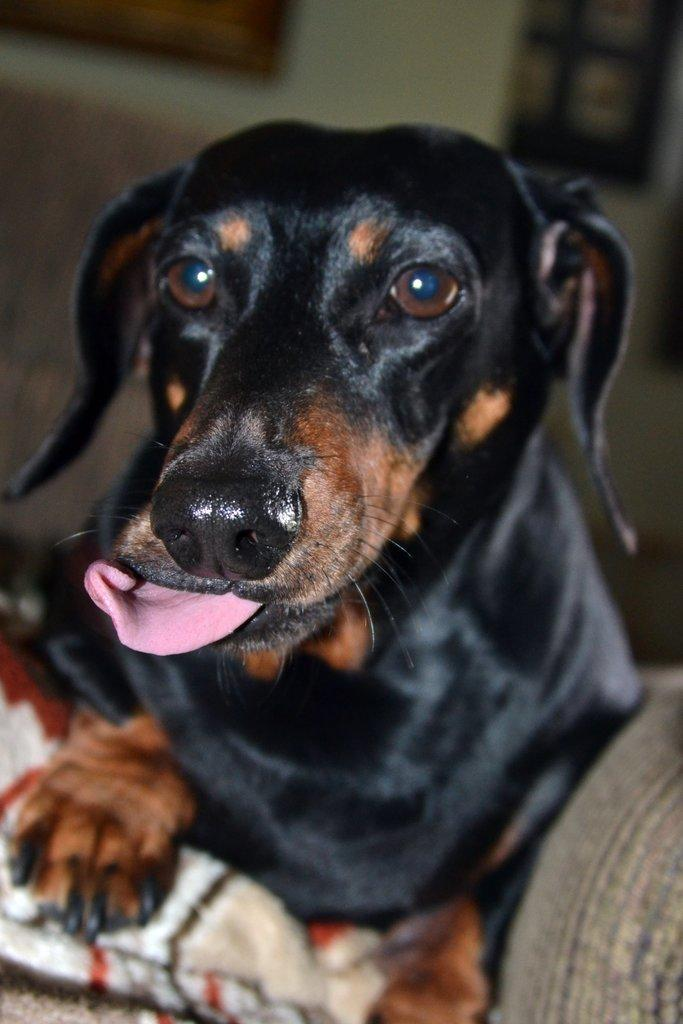What type of animal is in the image? There is a black color dog in the image. What is the dog doing in the image? The dog appears to be sitting on a couch. What can be seen behind the dog in the image? There is a wall visible in the background of the image, along with other items. What type of stone is the dog wearing as a skirt in the image? There is no stone or skirt present in the image; it features a black color dog sitting on a couch. 